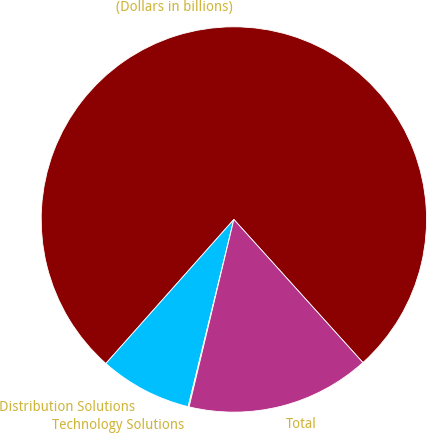<chart> <loc_0><loc_0><loc_500><loc_500><pie_chart><fcel>(Dollars in billions)<fcel>Distribution Solutions<fcel>Technology Solutions<fcel>Total<nl><fcel>76.76%<fcel>7.75%<fcel>0.08%<fcel>15.41%<nl></chart> 